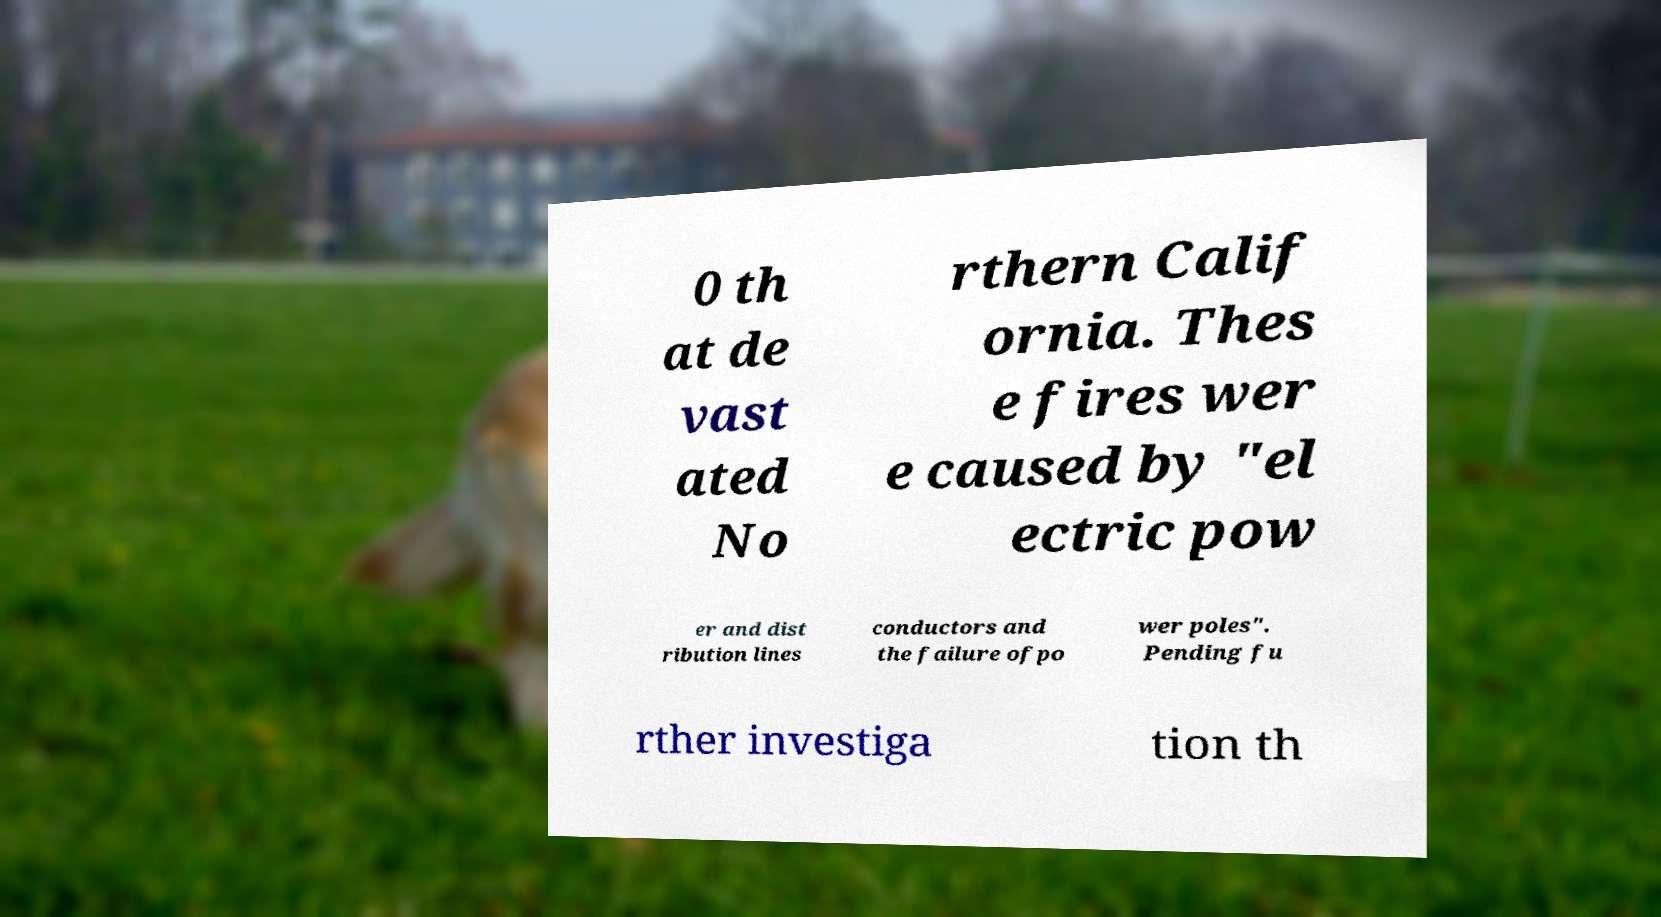Can you accurately transcribe the text from the provided image for me? 0 th at de vast ated No rthern Calif ornia. Thes e fires wer e caused by "el ectric pow er and dist ribution lines conductors and the failure ofpo wer poles". Pending fu rther investiga tion th 